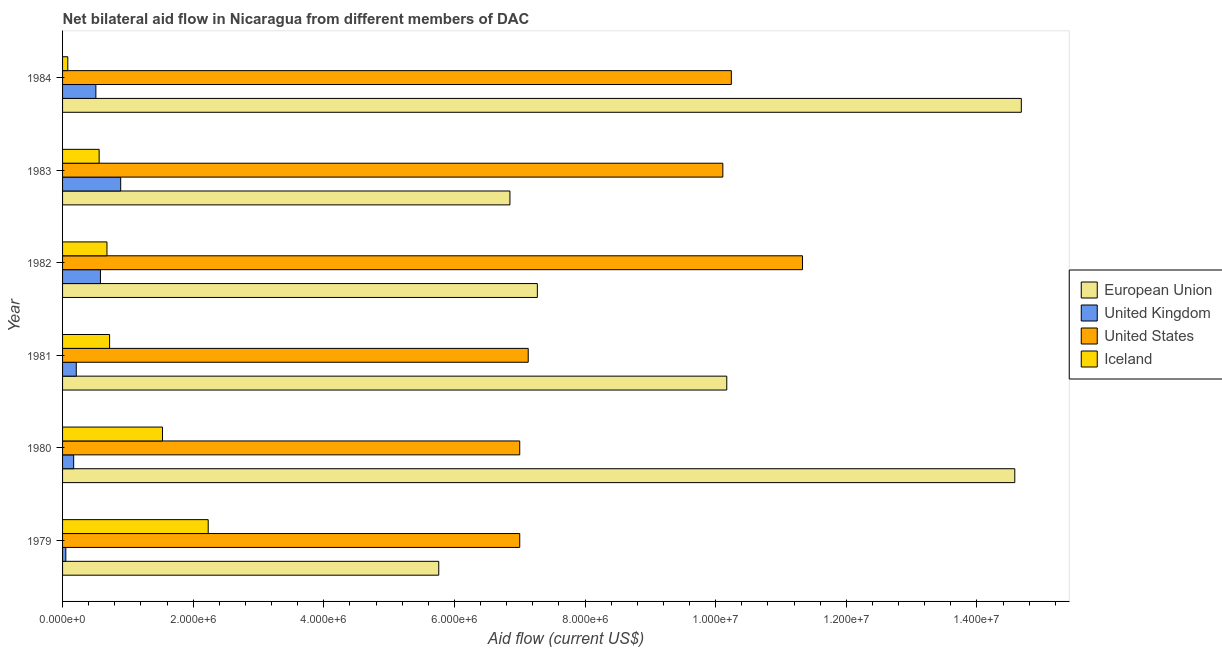Are the number of bars per tick equal to the number of legend labels?
Your response must be concise. Yes. Are the number of bars on each tick of the Y-axis equal?
Provide a short and direct response. Yes. How many bars are there on the 6th tick from the bottom?
Your answer should be compact. 4. What is the label of the 6th group of bars from the top?
Keep it short and to the point. 1979. What is the amount of aid given by us in 1981?
Your answer should be compact. 7.13e+06. Across all years, what is the maximum amount of aid given by us?
Your answer should be compact. 1.13e+07. Across all years, what is the minimum amount of aid given by eu?
Give a very brief answer. 5.76e+06. In which year was the amount of aid given by iceland minimum?
Your answer should be compact. 1984. What is the total amount of aid given by us in the graph?
Your response must be concise. 5.28e+07. What is the difference between the amount of aid given by iceland in 1983 and that in 1984?
Your response must be concise. 4.80e+05. What is the difference between the amount of aid given by us in 1984 and the amount of aid given by eu in 1983?
Offer a very short reply. 3.39e+06. What is the average amount of aid given by uk per year?
Provide a short and direct response. 4.02e+05. In the year 1983, what is the difference between the amount of aid given by iceland and amount of aid given by eu?
Your answer should be compact. -6.29e+06. What is the ratio of the amount of aid given by uk in 1980 to that in 1981?
Your answer should be very brief. 0.81. Is the amount of aid given by iceland in 1979 less than that in 1981?
Make the answer very short. No. What is the difference between the highest and the second highest amount of aid given by us?
Keep it short and to the point. 1.09e+06. What is the difference between the highest and the lowest amount of aid given by eu?
Make the answer very short. 8.92e+06. Is the sum of the amount of aid given by us in 1981 and 1984 greater than the maximum amount of aid given by uk across all years?
Your answer should be compact. Yes. Is it the case that in every year, the sum of the amount of aid given by us and amount of aid given by uk is greater than the sum of amount of aid given by eu and amount of aid given by iceland?
Provide a short and direct response. Yes. What does the 3rd bar from the top in 1980 represents?
Offer a very short reply. United Kingdom. What does the 2nd bar from the bottom in 1979 represents?
Keep it short and to the point. United Kingdom. How many bars are there?
Provide a short and direct response. 24. Does the graph contain grids?
Your answer should be very brief. No. Where does the legend appear in the graph?
Ensure brevity in your answer.  Center right. What is the title of the graph?
Your response must be concise. Net bilateral aid flow in Nicaragua from different members of DAC. Does "United States" appear as one of the legend labels in the graph?
Keep it short and to the point. Yes. What is the label or title of the X-axis?
Offer a very short reply. Aid flow (current US$). What is the Aid flow (current US$) in European Union in 1979?
Offer a terse response. 5.76e+06. What is the Aid flow (current US$) in United States in 1979?
Provide a short and direct response. 7.00e+06. What is the Aid flow (current US$) of Iceland in 1979?
Offer a very short reply. 2.23e+06. What is the Aid flow (current US$) in European Union in 1980?
Offer a terse response. 1.46e+07. What is the Aid flow (current US$) in Iceland in 1980?
Ensure brevity in your answer.  1.53e+06. What is the Aid flow (current US$) of European Union in 1981?
Keep it short and to the point. 1.02e+07. What is the Aid flow (current US$) of United States in 1981?
Offer a very short reply. 7.13e+06. What is the Aid flow (current US$) in Iceland in 1981?
Keep it short and to the point. 7.20e+05. What is the Aid flow (current US$) in European Union in 1982?
Offer a terse response. 7.27e+06. What is the Aid flow (current US$) in United Kingdom in 1982?
Keep it short and to the point. 5.80e+05. What is the Aid flow (current US$) in United States in 1982?
Make the answer very short. 1.13e+07. What is the Aid flow (current US$) of Iceland in 1982?
Provide a succinct answer. 6.80e+05. What is the Aid flow (current US$) of European Union in 1983?
Give a very brief answer. 6.85e+06. What is the Aid flow (current US$) in United Kingdom in 1983?
Offer a terse response. 8.90e+05. What is the Aid flow (current US$) of United States in 1983?
Provide a short and direct response. 1.01e+07. What is the Aid flow (current US$) of Iceland in 1983?
Your response must be concise. 5.60e+05. What is the Aid flow (current US$) of European Union in 1984?
Your answer should be compact. 1.47e+07. What is the Aid flow (current US$) in United Kingdom in 1984?
Your answer should be compact. 5.10e+05. What is the Aid flow (current US$) in United States in 1984?
Keep it short and to the point. 1.02e+07. Across all years, what is the maximum Aid flow (current US$) in European Union?
Provide a succinct answer. 1.47e+07. Across all years, what is the maximum Aid flow (current US$) of United Kingdom?
Provide a short and direct response. 8.90e+05. Across all years, what is the maximum Aid flow (current US$) in United States?
Your answer should be compact. 1.13e+07. Across all years, what is the maximum Aid flow (current US$) of Iceland?
Keep it short and to the point. 2.23e+06. Across all years, what is the minimum Aid flow (current US$) of European Union?
Make the answer very short. 5.76e+06. Across all years, what is the minimum Aid flow (current US$) of United States?
Offer a terse response. 7.00e+06. What is the total Aid flow (current US$) of European Union in the graph?
Offer a terse response. 5.93e+07. What is the total Aid flow (current US$) of United Kingdom in the graph?
Make the answer very short. 2.41e+06. What is the total Aid flow (current US$) of United States in the graph?
Keep it short and to the point. 5.28e+07. What is the total Aid flow (current US$) of Iceland in the graph?
Your response must be concise. 5.80e+06. What is the difference between the Aid flow (current US$) in European Union in 1979 and that in 1980?
Give a very brief answer. -8.82e+06. What is the difference between the Aid flow (current US$) of United States in 1979 and that in 1980?
Your answer should be compact. 0. What is the difference between the Aid flow (current US$) in Iceland in 1979 and that in 1980?
Offer a very short reply. 7.00e+05. What is the difference between the Aid flow (current US$) in European Union in 1979 and that in 1981?
Provide a succinct answer. -4.41e+06. What is the difference between the Aid flow (current US$) in Iceland in 1979 and that in 1981?
Provide a short and direct response. 1.51e+06. What is the difference between the Aid flow (current US$) of European Union in 1979 and that in 1982?
Your response must be concise. -1.51e+06. What is the difference between the Aid flow (current US$) in United Kingdom in 1979 and that in 1982?
Your answer should be very brief. -5.30e+05. What is the difference between the Aid flow (current US$) in United States in 1979 and that in 1982?
Offer a terse response. -4.33e+06. What is the difference between the Aid flow (current US$) in Iceland in 1979 and that in 1982?
Your answer should be very brief. 1.55e+06. What is the difference between the Aid flow (current US$) of European Union in 1979 and that in 1983?
Make the answer very short. -1.09e+06. What is the difference between the Aid flow (current US$) of United Kingdom in 1979 and that in 1983?
Offer a very short reply. -8.40e+05. What is the difference between the Aid flow (current US$) of United States in 1979 and that in 1983?
Make the answer very short. -3.11e+06. What is the difference between the Aid flow (current US$) in Iceland in 1979 and that in 1983?
Ensure brevity in your answer.  1.67e+06. What is the difference between the Aid flow (current US$) of European Union in 1979 and that in 1984?
Offer a very short reply. -8.92e+06. What is the difference between the Aid flow (current US$) of United Kingdom in 1979 and that in 1984?
Make the answer very short. -4.60e+05. What is the difference between the Aid flow (current US$) of United States in 1979 and that in 1984?
Keep it short and to the point. -3.24e+06. What is the difference between the Aid flow (current US$) of Iceland in 1979 and that in 1984?
Your answer should be compact. 2.15e+06. What is the difference between the Aid flow (current US$) in European Union in 1980 and that in 1981?
Your answer should be very brief. 4.41e+06. What is the difference between the Aid flow (current US$) of United States in 1980 and that in 1981?
Offer a very short reply. -1.30e+05. What is the difference between the Aid flow (current US$) in Iceland in 1980 and that in 1981?
Offer a terse response. 8.10e+05. What is the difference between the Aid flow (current US$) of European Union in 1980 and that in 1982?
Your answer should be compact. 7.31e+06. What is the difference between the Aid flow (current US$) in United Kingdom in 1980 and that in 1982?
Provide a succinct answer. -4.10e+05. What is the difference between the Aid flow (current US$) in United States in 1980 and that in 1982?
Make the answer very short. -4.33e+06. What is the difference between the Aid flow (current US$) in Iceland in 1980 and that in 1982?
Offer a terse response. 8.50e+05. What is the difference between the Aid flow (current US$) in European Union in 1980 and that in 1983?
Your response must be concise. 7.73e+06. What is the difference between the Aid flow (current US$) in United Kingdom in 1980 and that in 1983?
Give a very brief answer. -7.20e+05. What is the difference between the Aid flow (current US$) in United States in 1980 and that in 1983?
Provide a short and direct response. -3.11e+06. What is the difference between the Aid flow (current US$) of Iceland in 1980 and that in 1983?
Provide a succinct answer. 9.70e+05. What is the difference between the Aid flow (current US$) of European Union in 1980 and that in 1984?
Your response must be concise. -1.00e+05. What is the difference between the Aid flow (current US$) in United States in 1980 and that in 1984?
Your response must be concise. -3.24e+06. What is the difference between the Aid flow (current US$) of Iceland in 1980 and that in 1984?
Give a very brief answer. 1.45e+06. What is the difference between the Aid flow (current US$) of European Union in 1981 and that in 1982?
Offer a very short reply. 2.90e+06. What is the difference between the Aid flow (current US$) in United Kingdom in 1981 and that in 1982?
Provide a succinct answer. -3.70e+05. What is the difference between the Aid flow (current US$) of United States in 1981 and that in 1982?
Give a very brief answer. -4.20e+06. What is the difference between the Aid flow (current US$) in Iceland in 1981 and that in 1982?
Offer a terse response. 4.00e+04. What is the difference between the Aid flow (current US$) of European Union in 1981 and that in 1983?
Offer a very short reply. 3.32e+06. What is the difference between the Aid flow (current US$) in United Kingdom in 1981 and that in 1983?
Your answer should be very brief. -6.80e+05. What is the difference between the Aid flow (current US$) of United States in 1981 and that in 1983?
Your response must be concise. -2.98e+06. What is the difference between the Aid flow (current US$) in Iceland in 1981 and that in 1983?
Provide a succinct answer. 1.60e+05. What is the difference between the Aid flow (current US$) in European Union in 1981 and that in 1984?
Keep it short and to the point. -4.51e+06. What is the difference between the Aid flow (current US$) of United Kingdom in 1981 and that in 1984?
Ensure brevity in your answer.  -3.00e+05. What is the difference between the Aid flow (current US$) of United States in 1981 and that in 1984?
Make the answer very short. -3.11e+06. What is the difference between the Aid flow (current US$) in Iceland in 1981 and that in 1984?
Provide a succinct answer. 6.40e+05. What is the difference between the Aid flow (current US$) of European Union in 1982 and that in 1983?
Keep it short and to the point. 4.20e+05. What is the difference between the Aid flow (current US$) of United Kingdom in 1982 and that in 1983?
Provide a short and direct response. -3.10e+05. What is the difference between the Aid flow (current US$) in United States in 1982 and that in 1983?
Keep it short and to the point. 1.22e+06. What is the difference between the Aid flow (current US$) of European Union in 1982 and that in 1984?
Keep it short and to the point. -7.41e+06. What is the difference between the Aid flow (current US$) of United Kingdom in 1982 and that in 1984?
Provide a succinct answer. 7.00e+04. What is the difference between the Aid flow (current US$) of United States in 1982 and that in 1984?
Make the answer very short. 1.09e+06. What is the difference between the Aid flow (current US$) of Iceland in 1982 and that in 1984?
Your response must be concise. 6.00e+05. What is the difference between the Aid flow (current US$) of European Union in 1983 and that in 1984?
Provide a succinct answer. -7.83e+06. What is the difference between the Aid flow (current US$) in United States in 1983 and that in 1984?
Make the answer very short. -1.30e+05. What is the difference between the Aid flow (current US$) of European Union in 1979 and the Aid flow (current US$) of United Kingdom in 1980?
Your response must be concise. 5.59e+06. What is the difference between the Aid flow (current US$) of European Union in 1979 and the Aid flow (current US$) of United States in 1980?
Offer a terse response. -1.24e+06. What is the difference between the Aid flow (current US$) in European Union in 1979 and the Aid flow (current US$) in Iceland in 1980?
Your response must be concise. 4.23e+06. What is the difference between the Aid flow (current US$) in United Kingdom in 1979 and the Aid flow (current US$) in United States in 1980?
Ensure brevity in your answer.  -6.95e+06. What is the difference between the Aid flow (current US$) in United Kingdom in 1979 and the Aid flow (current US$) in Iceland in 1980?
Offer a very short reply. -1.48e+06. What is the difference between the Aid flow (current US$) in United States in 1979 and the Aid flow (current US$) in Iceland in 1980?
Ensure brevity in your answer.  5.47e+06. What is the difference between the Aid flow (current US$) of European Union in 1979 and the Aid flow (current US$) of United Kingdom in 1981?
Provide a short and direct response. 5.55e+06. What is the difference between the Aid flow (current US$) in European Union in 1979 and the Aid flow (current US$) in United States in 1981?
Make the answer very short. -1.37e+06. What is the difference between the Aid flow (current US$) of European Union in 1979 and the Aid flow (current US$) of Iceland in 1981?
Keep it short and to the point. 5.04e+06. What is the difference between the Aid flow (current US$) in United Kingdom in 1979 and the Aid flow (current US$) in United States in 1981?
Ensure brevity in your answer.  -7.08e+06. What is the difference between the Aid flow (current US$) in United Kingdom in 1979 and the Aid flow (current US$) in Iceland in 1981?
Your response must be concise. -6.70e+05. What is the difference between the Aid flow (current US$) in United States in 1979 and the Aid flow (current US$) in Iceland in 1981?
Ensure brevity in your answer.  6.28e+06. What is the difference between the Aid flow (current US$) in European Union in 1979 and the Aid flow (current US$) in United Kingdom in 1982?
Give a very brief answer. 5.18e+06. What is the difference between the Aid flow (current US$) of European Union in 1979 and the Aid flow (current US$) of United States in 1982?
Provide a succinct answer. -5.57e+06. What is the difference between the Aid flow (current US$) in European Union in 1979 and the Aid flow (current US$) in Iceland in 1982?
Your response must be concise. 5.08e+06. What is the difference between the Aid flow (current US$) of United Kingdom in 1979 and the Aid flow (current US$) of United States in 1982?
Make the answer very short. -1.13e+07. What is the difference between the Aid flow (current US$) in United Kingdom in 1979 and the Aid flow (current US$) in Iceland in 1982?
Ensure brevity in your answer.  -6.30e+05. What is the difference between the Aid flow (current US$) in United States in 1979 and the Aid flow (current US$) in Iceland in 1982?
Provide a succinct answer. 6.32e+06. What is the difference between the Aid flow (current US$) of European Union in 1979 and the Aid flow (current US$) of United Kingdom in 1983?
Ensure brevity in your answer.  4.87e+06. What is the difference between the Aid flow (current US$) of European Union in 1979 and the Aid flow (current US$) of United States in 1983?
Keep it short and to the point. -4.35e+06. What is the difference between the Aid flow (current US$) in European Union in 1979 and the Aid flow (current US$) in Iceland in 1983?
Provide a succinct answer. 5.20e+06. What is the difference between the Aid flow (current US$) in United Kingdom in 1979 and the Aid flow (current US$) in United States in 1983?
Your answer should be very brief. -1.01e+07. What is the difference between the Aid flow (current US$) in United Kingdom in 1979 and the Aid flow (current US$) in Iceland in 1983?
Make the answer very short. -5.10e+05. What is the difference between the Aid flow (current US$) of United States in 1979 and the Aid flow (current US$) of Iceland in 1983?
Provide a succinct answer. 6.44e+06. What is the difference between the Aid flow (current US$) in European Union in 1979 and the Aid flow (current US$) in United Kingdom in 1984?
Give a very brief answer. 5.25e+06. What is the difference between the Aid flow (current US$) of European Union in 1979 and the Aid flow (current US$) of United States in 1984?
Your answer should be compact. -4.48e+06. What is the difference between the Aid flow (current US$) of European Union in 1979 and the Aid flow (current US$) of Iceland in 1984?
Offer a very short reply. 5.68e+06. What is the difference between the Aid flow (current US$) in United Kingdom in 1979 and the Aid flow (current US$) in United States in 1984?
Your response must be concise. -1.02e+07. What is the difference between the Aid flow (current US$) in United Kingdom in 1979 and the Aid flow (current US$) in Iceland in 1984?
Your answer should be compact. -3.00e+04. What is the difference between the Aid flow (current US$) in United States in 1979 and the Aid flow (current US$) in Iceland in 1984?
Your response must be concise. 6.92e+06. What is the difference between the Aid flow (current US$) in European Union in 1980 and the Aid flow (current US$) in United Kingdom in 1981?
Offer a terse response. 1.44e+07. What is the difference between the Aid flow (current US$) of European Union in 1980 and the Aid flow (current US$) of United States in 1981?
Provide a short and direct response. 7.45e+06. What is the difference between the Aid flow (current US$) of European Union in 1980 and the Aid flow (current US$) of Iceland in 1981?
Keep it short and to the point. 1.39e+07. What is the difference between the Aid flow (current US$) of United Kingdom in 1980 and the Aid flow (current US$) of United States in 1981?
Your response must be concise. -6.96e+06. What is the difference between the Aid flow (current US$) in United Kingdom in 1980 and the Aid flow (current US$) in Iceland in 1981?
Offer a very short reply. -5.50e+05. What is the difference between the Aid flow (current US$) in United States in 1980 and the Aid flow (current US$) in Iceland in 1981?
Your response must be concise. 6.28e+06. What is the difference between the Aid flow (current US$) in European Union in 1980 and the Aid flow (current US$) in United Kingdom in 1982?
Your response must be concise. 1.40e+07. What is the difference between the Aid flow (current US$) in European Union in 1980 and the Aid flow (current US$) in United States in 1982?
Offer a terse response. 3.25e+06. What is the difference between the Aid flow (current US$) in European Union in 1980 and the Aid flow (current US$) in Iceland in 1982?
Provide a succinct answer. 1.39e+07. What is the difference between the Aid flow (current US$) of United Kingdom in 1980 and the Aid flow (current US$) of United States in 1982?
Your answer should be compact. -1.12e+07. What is the difference between the Aid flow (current US$) of United Kingdom in 1980 and the Aid flow (current US$) of Iceland in 1982?
Provide a short and direct response. -5.10e+05. What is the difference between the Aid flow (current US$) in United States in 1980 and the Aid flow (current US$) in Iceland in 1982?
Your response must be concise. 6.32e+06. What is the difference between the Aid flow (current US$) in European Union in 1980 and the Aid flow (current US$) in United Kingdom in 1983?
Offer a terse response. 1.37e+07. What is the difference between the Aid flow (current US$) of European Union in 1980 and the Aid flow (current US$) of United States in 1983?
Keep it short and to the point. 4.47e+06. What is the difference between the Aid flow (current US$) of European Union in 1980 and the Aid flow (current US$) of Iceland in 1983?
Your response must be concise. 1.40e+07. What is the difference between the Aid flow (current US$) of United Kingdom in 1980 and the Aid flow (current US$) of United States in 1983?
Make the answer very short. -9.94e+06. What is the difference between the Aid flow (current US$) of United Kingdom in 1980 and the Aid flow (current US$) of Iceland in 1983?
Give a very brief answer. -3.90e+05. What is the difference between the Aid flow (current US$) in United States in 1980 and the Aid flow (current US$) in Iceland in 1983?
Make the answer very short. 6.44e+06. What is the difference between the Aid flow (current US$) of European Union in 1980 and the Aid flow (current US$) of United Kingdom in 1984?
Provide a succinct answer. 1.41e+07. What is the difference between the Aid flow (current US$) of European Union in 1980 and the Aid flow (current US$) of United States in 1984?
Give a very brief answer. 4.34e+06. What is the difference between the Aid flow (current US$) of European Union in 1980 and the Aid flow (current US$) of Iceland in 1984?
Ensure brevity in your answer.  1.45e+07. What is the difference between the Aid flow (current US$) of United Kingdom in 1980 and the Aid flow (current US$) of United States in 1984?
Make the answer very short. -1.01e+07. What is the difference between the Aid flow (current US$) in United States in 1980 and the Aid flow (current US$) in Iceland in 1984?
Your answer should be compact. 6.92e+06. What is the difference between the Aid flow (current US$) of European Union in 1981 and the Aid flow (current US$) of United Kingdom in 1982?
Make the answer very short. 9.59e+06. What is the difference between the Aid flow (current US$) in European Union in 1981 and the Aid flow (current US$) in United States in 1982?
Provide a succinct answer. -1.16e+06. What is the difference between the Aid flow (current US$) of European Union in 1981 and the Aid flow (current US$) of Iceland in 1982?
Provide a succinct answer. 9.49e+06. What is the difference between the Aid flow (current US$) of United Kingdom in 1981 and the Aid flow (current US$) of United States in 1982?
Ensure brevity in your answer.  -1.11e+07. What is the difference between the Aid flow (current US$) in United Kingdom in 1981 and the Aid flow (current US$) in Iceland in 1982?
Your answer should be compact. -4.70e+05. What is the difference between the Aid flow (current US$) of United States in 1981 and the Aid flow (current US$) of Iceland in 1982?
Ensure brevity in your answer.  6.45e+06. What is the difference between the Aid flow (current US$) in European Union in 1981 and the Aid flow (current US$) in United Kingdom in 1983?
Offer a terse response. 9.28e+06. What is the difference between the Aid flow (current US$) in European Union in 1981 and the Aid flow (current US$) in Iceland in 1983?
Your response must be concise. 9.61e+06. What is the difference between the Aid flow (current US$) of United Kingdom in 1981 and the Aid flow (current US$) of United States in 1983?
Offer a terse response. -9.90e+06. What is the difference between the Aid flow (current US$) of United Kingdom in 1981 and the Aid flow (current US$) of Iceland in 1983?
Provide a succinct answer. -3.50e+05. What is the difference between the Aid flow (current US$) of United States in 1981 and the Aid flow (current US$) of Iceland in 1983?
Your response must be concise. 6.57e+06. What is the difference between the Aid flow (current US$) of European Union in 1981 and the Aid flow (current US$) of United Kingdom in 1984?
Make the answer very short. 9.66e+06. What is the difference between the Aid flow (current US$) in European Union in 1981 and the Aid flow (current US$) in Iceland in 1984?
Provide a succinct answer. 1.01e+07. What is the difference between the Aid flow (current US$) in United Kingdom in 1981 and the Aid flow (current US$) in United States in 1984?
Your answer should be very brief. -1.00e+07. What is the difference between the Aid flow (current US$) in United States in 1981 and the Aid flow (current US$) in Iceland in 1984?
Offer a terse response. 7.05e+06. What is the difference between the Aid flow (current US$) in European Union in 1982 and the Aid flow (current US$) in United Kingdom in 1983?
Provide a succinct answer. 6.38e+06. What is the difference between the Aid flow (current US$) of European Union in 1982 and the Aid flow (current US$) of United States in 1983?
Offer a very short reply. -2.84e+06. What is the difference between the Aid flow (current US$) of European Union in 1982 and the Aid flow (current US$) of Iceland in 1983?
Provide a succinct answer. 6.71e+06. What is the difference between the Aid flow (current US$) in United Kingdom in 1982 and the Aid flow (current US$) in United States in 1983?
Make the answer very short. -9.53e+06. What is the difference between the Aid flow (current US$) in United Kingdom in 1982 and the Aid flow (current US$) in Iceland in 1983?
Provide a short and direct response. 2.00e+04. What is the difference between the Aid flow (current US$) of United States in 1982 and the Aid flow (current US$) of Iceland in 1983?
Provide a succinct answer. 1.08e+07. What is the difference between the Aid flow (current US$) of European Union in 1982 and the Aid flow (current US$) of United Kingdom in 1984?
Your response must be concise. 6.76e+06. What is the difference between the Aid flow (current US$) of European Union in 1982 and the Aid flow (current US$) of United States in 1984?
Give a very brief answer. -2.97e+06. What is the difference between the Aid flow (current US$) of European Union in 1982 and the Aid flow (current US$) of Iceland in 1984?
Offer a terse response. 7.19e+06. What is the difference between the Aid flow (current US$) of United Kingdom in 1982 and the Aid flow (current US$) of United States in 1984?
Provide a succinct answer. -9.66e+06. What is the difference between the Aid flow (current US$) of United States in 1982 and the Aid flow (current US$) of Iceland in 1984?
Make the answer very short. 1.12e+07. What is the difference between the Aid flow (current US$) of European Union in 1983 and the Aid flow (current US$) of United Kingdom in 1984?
Give a very brief answer. 6.34e+06. What is the difference between the Aid flow (current US$) of European Union in 1983 and the Aid flow (current US$) of United States in 1984?
Your answer should be compact. -3.39e+06. What is the difference between the Aid flow (current US$) of European Union in 1983 and the Aid flow (current US$) of Iceland in 1984?
Keep it short and to the point. 6.77e+06. What is the difference between the Aid flow (current US$) of United Kingdom in 1983 and the Aid flow (current US$) of United States in 1984?
Your answer should be compact. -9.35e+06. What is the difference between the Aid flow (current US$) of United Kingdom in 1983 and the Aid flow (current US$) of Iceland in 1984?
Offer a very short reply. 8.10e+05. What is the difference between the Aid flow (current US$) in United States in 1983 and the Aid flow (current US$) in Iceland in 1984?
Keep it short and to the point. 1.00e+07. What is the average Aid flow (current US$) of European Union per year?
Offer a very short reply. 9.88e+06. What is the average Aid flow (current US$) of United Kingdom per year?
Ensure brevity in your answer.  4.02e+05. What is the average Aid flow (current US$) in United States per year?
Provide a succinct answer. 8.80e+06. What is the average Aid flow (current US$) in Iceland per year?
Offer a terse response. 9.67e+05. In the year 1979, what is the difference between the Aid flow (current US$) in European Union and Aid flow (current US$) in United Kingdom?
Offer a terse response. 5.71e+06. In the year 1979, what is the difference between the Aid flow (current US$) of European Union and Aid flow (current US$) of United States?
Give a very brief answer. -1.24e+06. In the year 1979, what is the difference between the Aid flow (current US$) in European Union and Aid flow (current US$) in Iceland?
Give a very brief answer. 3.53e+06. In the year 1979, what is the difference between the Aid flow (current US$) of United Kingdom and Aid flow (current US$) of United States?
Provide a short and direct response. -6.95e+06. In the year 1979, what is the difference between the Aid flow (current US$) of United Kingdom and Aid flow (current US$) of Iceland?
Give a very brief answer. -2.18e+06. In the year 1979, what is the difference between the Aid flow (current US$) of United States and Aid flow (current US$) of Iceland?
Your answer should be compact. 4.77e+06. In the year 1980, what is the difference between the Aid flow (current US$) of European Union and Aid flow (current US$) of United Kingdom?
Your answer should be very brief. 1.44e+07. In the year 1980, what is the difference between the Aid flow (current US$) in European Union and Aid flow (current US$) in United States?
Ensure brevity in your answer.  7.58e+06. In the year 1980, what is the difference between the Aid flow (current US$) of European Union and Aid flow (current US$) of Iceland?
Give a very brief answer. 1.30e+07. In the year 1980, what is the difference between the Aid flow (current US$) in United Kingdom and Aid flow (current US$) in United States?
Your response must be concise. -6.83e+06. In the year 1980, what is the difference between the Aid flow (current US$) of United Kingdom and Aid flow (current US$) of Iceland?
Provide a succinct answer. -1.36e+06. In the year 1980, what is the difference between the Aid flow (current US$) of United States and Aid flow (current US$) of Iceland?
Offer a very short reply. 5.47e+06. In the year 1981, what is the difference between the Aid flow (current US$) of European Union and Aid flow (current US$) of United Kingdom?
Your response must be concise. 9.96e+06. In the year 1981, what is the difference between the Aid flow (current US$) of European Union and Aid flow (current US$) of United States?
Provide a short and direct response. 3.04e+06. In the year 1981, what is the difference between the Aid flow (current US$) in European Union and Aid flow (current US$) in Iceland?
Your answer should be compact. 9.45e+06. In the year 1981, what is the difference between the Aid flow (current US$) in United Kingdom and Aid flow (current US$) in United States?
Ensure brevity in your answer.  -6.92e+06. In the year 1981, what is the difference between the Aid flow (current US$) in United Kingdom and Aid flow (current US$) in Iceland?
Your answer should be very brief. -5.10e+05. In the year 1981, what is the difference between the Aid flow (current US$) in United States and Aid flow (current US$) in Iceland?
Give a very brief answer. 6.41e+06. In the year 1982, what is the difference between the Aid flow (current US$) in European Union and Aid flow (current US$) in United Kingdom?
Give a very brief answer. 6.69e+06. In the year 1982, what is the difference between the Aid flow (current US$) of European Union and Aid flow (current US$) of United States?
Your response must be concise. -4.06e+06. In the year 1982, what is the difference between the Aid flow (current US$) of European Union and Aid flow (current US$) of Iceland?
Offer a very short reply. 6.59e+06. In the year 1982, what is the difference between the Aid flow (current US$) in United Kingdom and Aid flow (current US$) in United States?
Ensure brevity in your answer.  -1.08e+07. In the year 1982, what is the difference between the Aid flow (current US$) of United States and Aid flow (current US$) of Iceland?
Offer a terse response. 1.06e+07. In the year 1983, what is the difference between the Aid flow (current US$) of European Union and Aid flow (current US$) of United Kingdom?
Make the answer very short. 5.96e+06. In the year 1983, what is the difference between the Aid flow (current US$) in European Union and Aid flow (current US$) in United States?
Provide a succinct answer. -3.26e+06. In the year 1983, what is the difference between the Aid flow (current US$) of European Union and Aid flow (current US$) of Iceland?
Your answer should be very brief. 6.29e+06. In the year 1983, what is the difference between the Aid flow (current US$) in United Kingdom and Aid flow (current US$) in United States?
Offer a very short reply. -9.22e+06. In the year 1983, what is the difference between the Aid flow (current US$) of United Kingdom and Aid flow (current US$) of Iceland?
Offer a very short reply. 3.30e+05. In the year 1983, what is the difference between the Aid flow (current US$) in United States and Aid flow (current US$) in Iceland?
Make the answer very short. 9.55e+06. In the year 1984, what is the difference between the Aid flow (current US$) of European Union and Aid flow (current US$) of United Kingdom?
Give a very brief answer. 1.42e+07. In the year 1984, what is the difference between the Aid flow (current US$) of European Union and Aid flow (current US$) of United States?
Make the answer very short. 4.44e+06. In the year 1984, what is the difference between the Aid flow (current US$) in European Union and Aid flow (current US$) in Iceland?
Your answer should be compact. 1.46e+07. In the year 1984, what is the difference between the Aid flow (current US$) of United Kingdom and Aid flow (current US$) of United States?
Make the answer very short. -9.73e+06. In the year 1984, what is the difference between the Aid flow (current US$) of United Kingdom and Aid flow (current US$) of Iceland?
Ensure brevity in your answer.  4.30e+05. In the year 1984, what is the difference between the Aid flow (current US$) in United States and Aid flow (current US$) in Iceland?
Your answer should be very brief. 1.02e+07. What is the ratio of the Aid flow (current US$) in European Union in 1979 to that in 1980?
Offer a terse response. 0.4. What is the ratio of the Aid flow (current US$) in United Kingdom in 1979 to that in 1980?
Keep it short and to the point. 0.29. What is the ratio of the Aid flow (current US$) in Iceland in 1979 to that in 1980?
Offer a terse response. 1.46. What is the ratio of the Aid flow (current US$) in European Union in 1979 to that in 1981?
Provide a succinct answer. 0.57. What is the ratio of the Aid flow (current US$) of United Kingdom in 1979 to that in 1981?
Ensure brevity in your answer.  0.24. What is the ratio of the Aid flow (current US$) of United States in 1979 to that in 1981?
Offer a terse response. 0.98. What is the ratio of the Aid flow (current US$) of Iceland in 1979 to that in 1981?
Ensure brevity in your answer.  3.1. What is the ratio of the Aid flow (current US$) of European Union in 1979 to that in 1982?
Provide a succinct answer. 0.79. What is the ratio of the Aid flow (current US$) of United Kingdom in 1979 to that in 1982?
Provide a succinct answer. 0.09. What is the ratio of the Aid flow (current US$) in United States in 1979 to that in 1982?
Your answer should be compact. 0.62. What is the ratio of the Aid flow (current US$) of Iceland in 1979 to that in 1982?
Your response must be concise. 3.28. What is the ratio of the Aid flow (current US$) in European Union in 1979 to that in 1983?
Make the answer very short. 0.84. What is the ratio of the Aid flow (current US$) of United Kingdom in 1979 to that in 1983?
Your answer should be very brief. 0.06. What is the ratio of the Aid flow (current US$) of United States in 1979 to that in 1983?
Offer a terse response. 0.69. What is the ratio of the Aid flow (current US$) in Iceland in 1979 to that in 1983?
Give a very brief answer. 3.98. What is the ratio of the Aid flow (current US$) of European Union in 1979 to that in 1984?
Make the answer very short. 0.39. What is the ratio of the Aid flow (current US$) in United Kingdom in 1979 to that in 1984?
Offer a very short reply. 0.1. What is the ratio of the Aid flow (current US$) in United States in 1979 to that in 1984?
Your answer should be compact. 0.68. What is the ratio of the Aid flow (current US$) in Iceland in 1979 to that in 1984?
Provide a succinct answer. 27.88. What is the ratio of the Aid flow (current US$) in European Union in 1980 to that in 1981?
Keep it short and to the point. 1.43. What is the ratio of the Aid flow (current US$) of United Kingdom in 1980 to that in 1981?
Your answer should be compact. 0.81. What is the ratio of the Aid flow (current US$) in United States in 1980 to that in 1981?
Keep it short and to the point. 0.98. What is the ratio of the Aid flow (current US$) of Iceland in 1980 to that in 1981?
Offer a very short reply. 2.12. What is the ratio of the Aid flow (current US$) of European Union in 1980 to that in 1982?
Your response must be concise. 2.01. What is the ratio of the Aid flow (current US$) of United Kingdom in 1980 to that in 1982?
Offer a terse response. 0.29. What is the ratio of the Aid flow (current US$) of United States in 1980 to that in 1982?
Ensure brevity in your answer.  0.62. What is the ratio of the Aid flow (current US$) in Iceland in 1980 to that in 1982?
Your answer should be very brief. 2.25. What is the ratio of the Aid flow (current US$) of European Union in 1980 to that in 1983?
Provide a succinct answer. 2.13. What is the ratio of the Aid flow (current US$) of United Kingdom in 1980 to that in 1983?
Your answer should be very brief. 0.19. What is the ratio of the Aid flow (current US$) in United States in 1980 to that in 1983?
Your answer should be very brief. 0.69. What is the ratio of the Aid flow (current US$) of Iceland in 1980 to that in 1983?
Keep it short and to the point. 2.73. What is the ratio of the Aid flow (current US$) of European Union in 1980 to that in 1984?
Offer a terse response. 0.99. What is the ratio of the Aid flow (current US$) of United States in 1980 to that in 1984?
Provide a succinct answer. 0.68. What is the ratio of the Aid flow (current US$) of Iceland in 1980 to that in 1984?
Provide a succinct answer. 19.12. What is the ratio of the Aid flow (current US$) of European Union in 1981 to that in 1982?
Keep it short and to the point. 1.4. What is the ratio of the Aid flow (current US$) of United Kingdom in 1981 to that in 1982?
Provide a succinct answer. 0.36. What is the ratio of the Aid flow (current US$) in United States in 1981 to that in 1982?
Make the answer very short. 0.63. What is the ratio of the Aid flow (current US$) in Iceland in 1981 to that in 1982?
Your response must be concise. 1.06. What is the ratio of the Aid flow (current US$) in European Union in 1981 to that in 1983?
Keep it short and to the point. 1.48. What is the ratio of the Aid flow (current US$) of United Kingdom in 1981 to that in 1983?
Ensure brevity in your answer.  0.24. What is the ratio of the Aid flow (current US$) of United States in 1981 to that in 1983?
Offer a terse response. 0.71. What is the ratio of the Aid flow (current US$) of European Union in 1981 to that in 1984?
Give a very brief answer. 0.69. What is the ratio of the Aid flow (current US$) of United Kingdom in 1981 to that in 1984?
Make the answer very short. 0.41. What is the ratio of the Aid flow (current US$) in United States in 1981 to that in 1984?
Your answer should be very brief. 0.7. What is the ratio of the Aid flow (current US$) of European Union in 1982 to that in 1983?
Offer a terse response. 1.06. What is the ratio of the Aid flow (current US$) in United Kingdom in 1982 to that in 1983?
Provide a short and direct response. 0.65. What is the ratio of the Aid flow (current US$) in United States in 1982 to that in 1983?
Keep it short and to the point. 1.12. What is the ratio of the Aid flow (current US$) of Iceland in 1982 to that in 1983?
Make the answer very short. 1.21. What is the ratio of the Aid flow (current US$) of European Union in 1982 to that in 1984?
Offer a terse response. 0.5. What is the ratio of the Aid flow (current US$) in United Kingdom in 1982 to that in 1984?
Make the answer very short. 1.14. What is the ratio of the Aid flow (current US$) of United States in 1982 to that in 1984?
Make the answer very short. 1.11. What is the ratio of the Aid flow (current US$) of Iceland in 1982 to that in 1984?
Your response must be concise. 8.5. What is the ratio of the Aid flow (current US$) in European Union in 1983 to that in 1984?
Provide a short and direct response. 0.47. What is the ratio of the Aid flow (current US$) of United Kingdom in 1983 to that in 1984?
Your response must be concise. 1.75. What is the ratio of the Aid flow (current US$) in United States in 1983 to that in 1984?
Keep it short and to the point. 0.99. What is the difference between the highest and the second highest Aid flow (current US$) in United Kingdom?
Make the answer very short. 3.10e+05. What is the difference between the highest and the second highest Aid flow (current US$) of United States?
Make the answer very short. 1.09e+06. What is the difference between the highest and the lowest Aid flow (current US$) of European Union?
Give a very brief answer. 8.92e+06. What is the difference between the highest and the lowest Aid flow (current US$) of United Kingdom?
Provide a short and direct response. 8.40e+05. What is the difference between the highest and the lowest Aid flow (current US$) in United States?
Offer a very short reply. 4.33e+06. What is the difference between the highest and the lowest Aid flow (current US$) of Iceland?
Provide a short and direct response. 2.15e+06. 